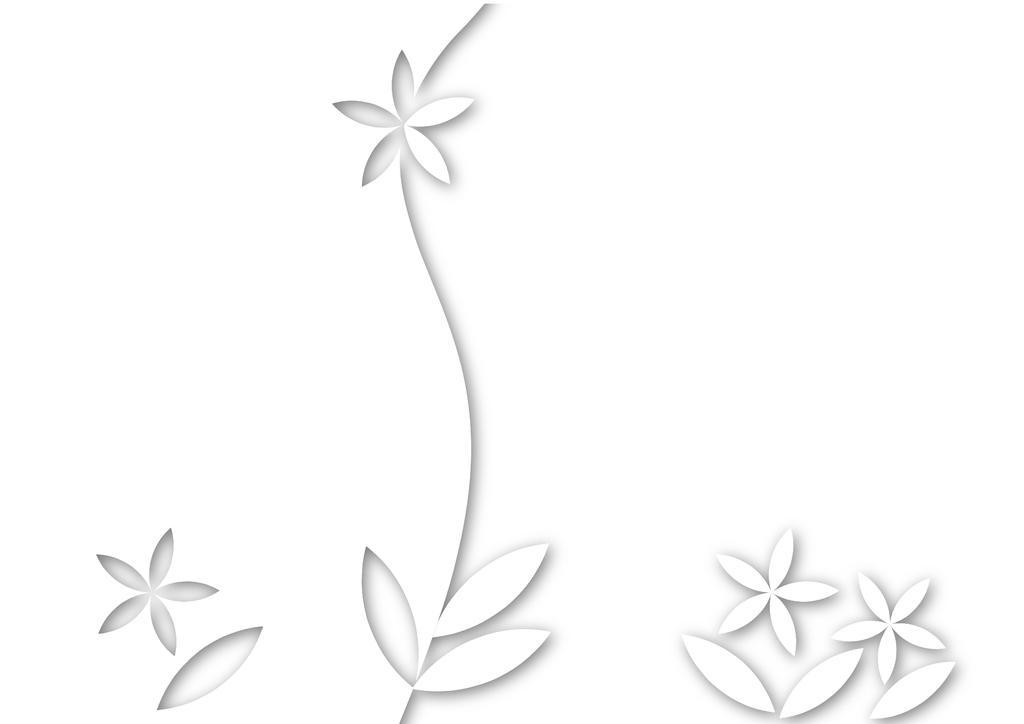Could you give a brief overview of what you see in this image? This is an edited image. Here I can see few artificial flowers. The background is in white color. 